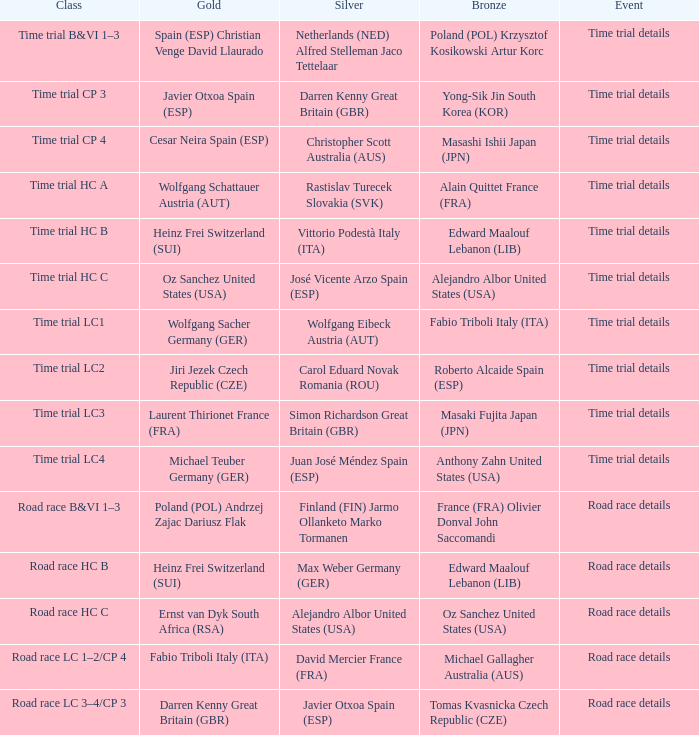Help me parse the entirety of this table. {'header': ['Class', 'Gold', 'Silver', 'Bronze', 'Event'], 'rows': [['Time trial B&VI 1–3', 'Spain (ESP) Christian Venge David Llaurado', 'Netherlands (NED) Alfred Stelleman Jaco Tettelaar', 'Poland (POL) Krzysztof Kosikowski Artur Korc', 'Time trial details'], ['Time trial CP 3', 'Javier Otxoa Spain (ESP)', 'Darren Kenny Great Britain (GBR)', 'Yong-Sik Jin South Korea (KOR)', 'Time trial details'], ['Time trial CP 4', 'Cesar Neira Spain (ESP)', 'Christopher Scott Australia (AUS)', 'Masashi Ishii Japan (JPN)', 'Time trial details'], ['Time trial HC A', 'Wolfgang Schattauer Austria (AUT)', 'Rastislav Turecek Slovakia (SVK)', 'Alain Quittet France (FRA)', 'Time trial details'], ['Time trial HC B', 'Heinz Frei Switzerland (SUI)', 'Vittorio Podestà Italy (ITA)', 'Edward Maalouf Lebanon (LIB)', 'Time trial details'], ['Time trial HC C', 'Oz Sanchez United States (USA)', 'José Vicente Arzo Spain (ESP)', 'Alejandro Albor United States (USA)', 'Time trial details'], ['Time trial LC1', 'Wolfgang Sacher Germany (GER)', 'Wolfgang Eibeck Austria (AUT)', 'Fabio Triboli Italy (ITA)', 'Time trial details'], ['Time trial LC2', 'Jiri Jezek Czech Republic (CZE)', 'Carol Eduard Novak Romania (ROU)', 'Roberto Alcaide Spain (ESP)', 'Time trial details'], ['Time trial LC3', 'Laurent Thirionet France (FRA)', 'Simon Richardson Great Britain (GBR)', 'Masaki Fujita Japan (JPN)', 'Time trial details'], ['Time trial LC4', 'Michael Teuber Germany (GER)', 'Juan José Méndez Spain (ESP)', 'Anthony Zahn United States (USA)', 'Time trial details'], ['Road race B&VI 1–3', 'Poland (POL) Andrzej Zajac Dariusz Flak', 'Finland (FIN) Jarmo Ollanketo Marko Tormanen', 'France (FRA) Olivier Donval John Saccomandi', 'Road race details'], ['Road race HC B', 'Heinz Frei Switzerland (SUI)', 'Max Weber Germany (GER)', 'Edward Maalouf Lebanon (LIB)', 'Road race details'], ['Road race HC C', 'Ernst van Dyk South Africa (RSA)', 'Alejandro Albor United States (USA)', 'Oz Sanchez United States (USA)', 'Road race details'], ['Road race LC 1–2/CP 4', 'Fabio Triboli Italy (ITA)', 'David Mercier France (FRA)', 'Michael Gallagher Australia (AUS)', 'Road race details'], ['Road race LC 3–4/CP 3', 'Darren Kenny Great Britain (GBR)', 'Javier Otxoa Spain (ESP)', 'Tomas Kvasnicka Czech Republic (CZE)', 'Road race details']]} Who received gold when the event is road race details and silver is max weber germany (ger)? Heinz Frei Switzerland (SUI). 